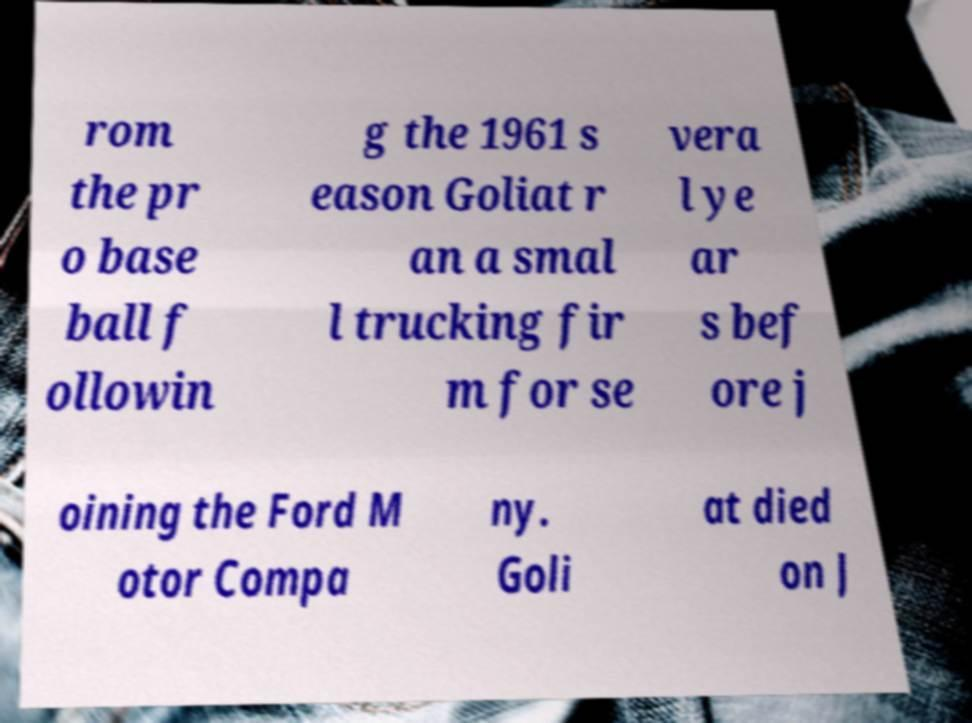Could you assist in decoding the text presented in this image and type it out clearly? rom the pr o base ball f ollowin g the 1961 s eason Goliat r an a smal l trucking fir m for se vera l ye ar s bef ore j oining the Ford M otor Compa ny. Goli at died on J 